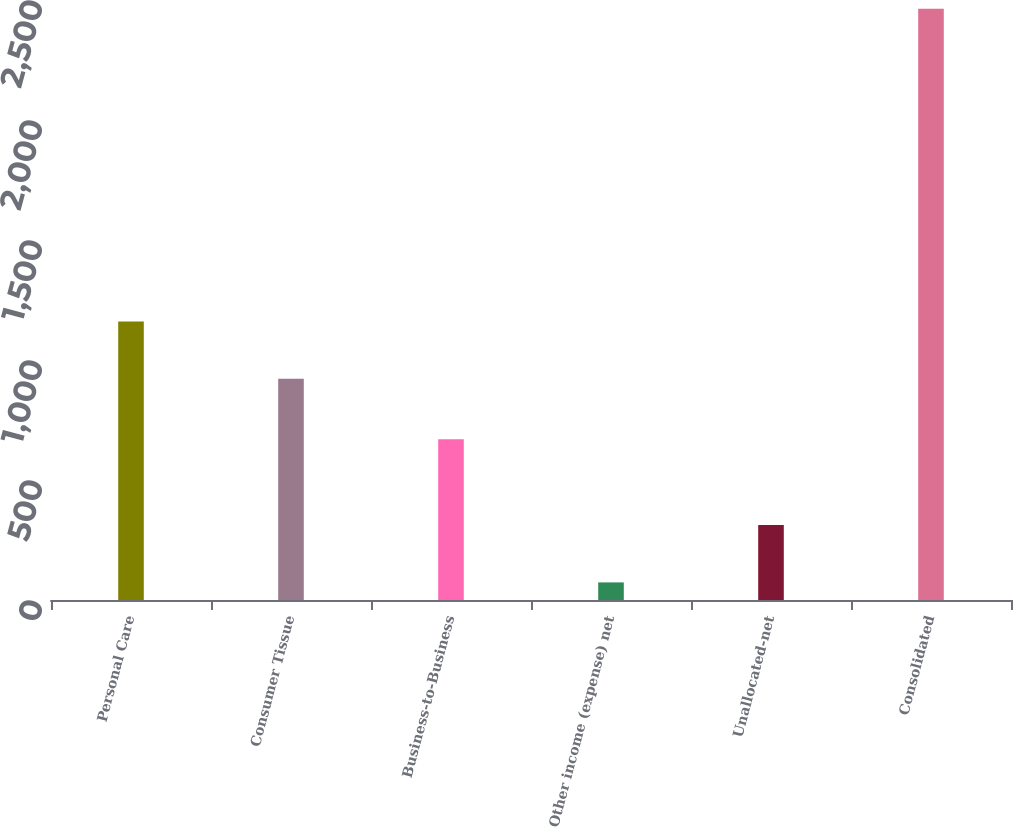Convert chart. <chart><loc_0><loc_0><loc_500><loc_500><bar_chart><fcel>Personal Care<fcel>Consumer Tissue<fcel>Business-to-Business<fcel>Other income (expense) net<fcel>Unallocated-net<fcel>Consolidated<nl><fcel>1160.75<fcel>921.7<fcel>670<fcel>73.3<fcel>312.35<fcel>2463.8<nl></chart> 